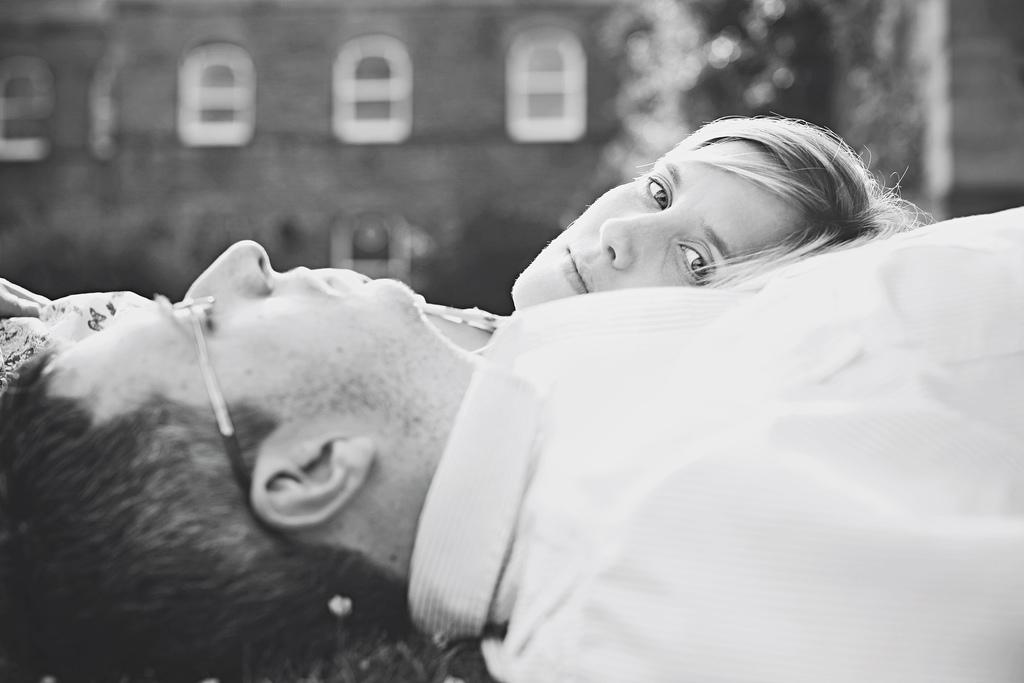How many people are in the image? There are two persons in the image. What is the position of their heads in relation to each other? The heads of the two persons are placed opposite sides of each other. What can be seen in the background of the image? There is a building in the background of the image. What type of bun is being used to hold the attention of the two persons in the image? There is no bun present in the image, nor is there any indication that the two persons are holding attention. 